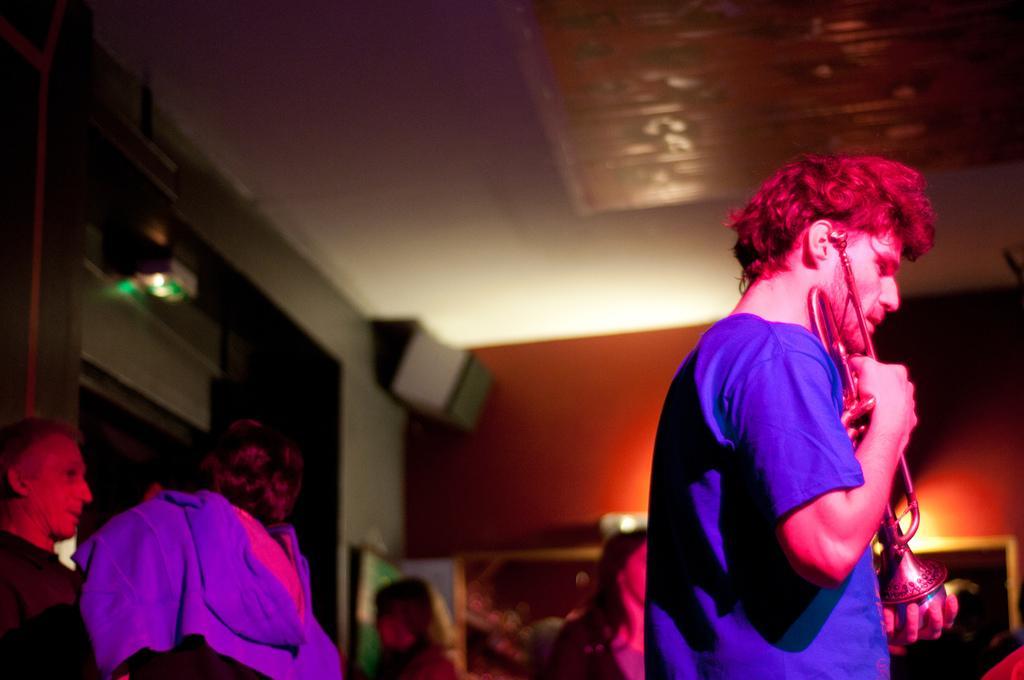Describe this image in one or two sentences. In this image I can see group of people. In front the person is holding the musical instrument and the person is wearing blue color shirt. In the background I can see few frames attached to the wall and the wall is in brown color. 